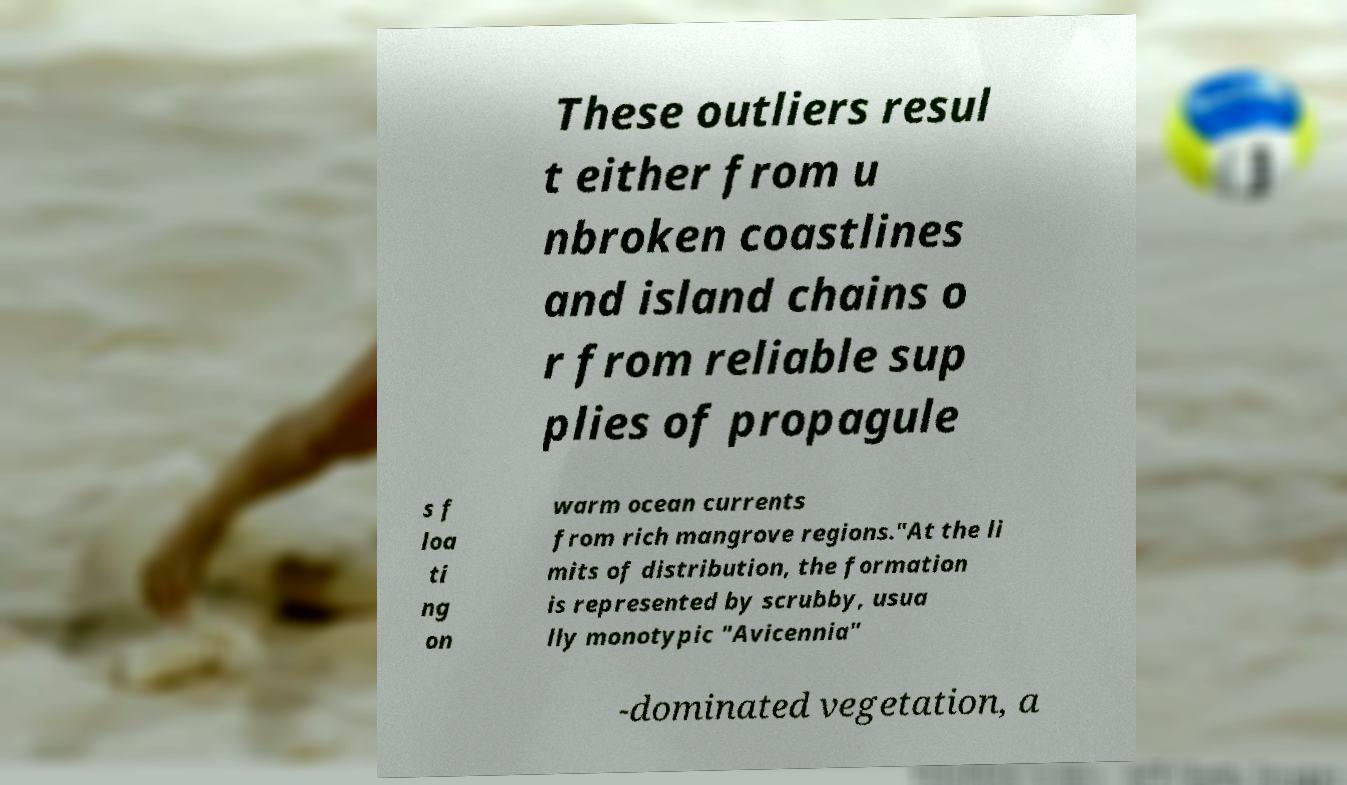Can you accurately transcribe the text from the provided image for me? These outliers resul t either from u nbroken coastlines and island chains o r from reliable sup plies of propagule s f loa ti ng on warm ocean currents from rich mangrove regions."At the li mits of distribution, the formation is represented by scrubby, usua lly monotypic "Avicennia" -dominated vegetation, a 